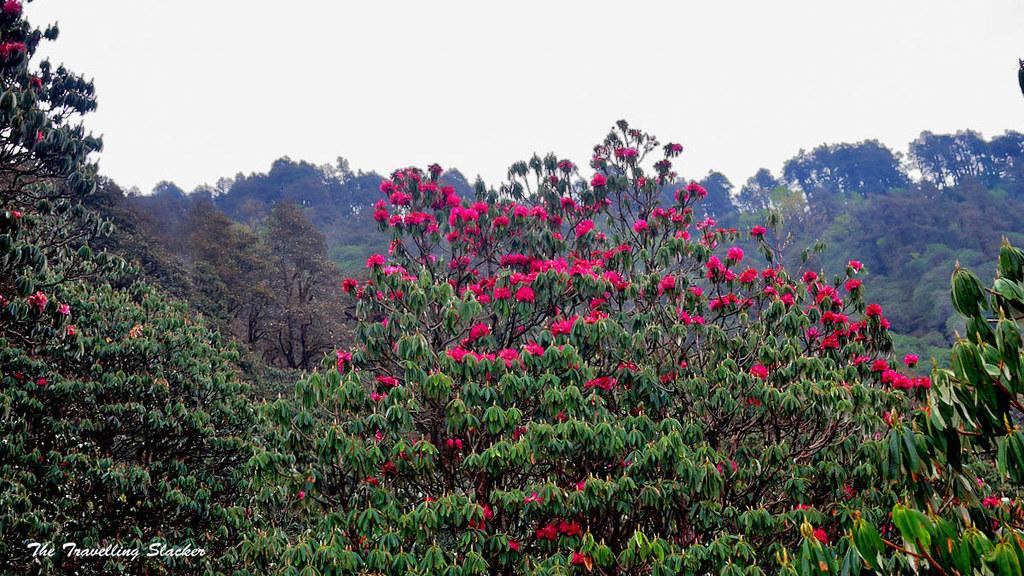What can be seen in the background of the image? The sky is visible in the image. What type of vegetation is present in the image? There are trees with flowers in the image. What type of car is parked under the trees in the image? There is no car present in the image; it only features the sky and trees with flowers. What kind of stew is being prepared in the image? There is no stew being prepared in the image; it only features the sky and trees with flowers. 